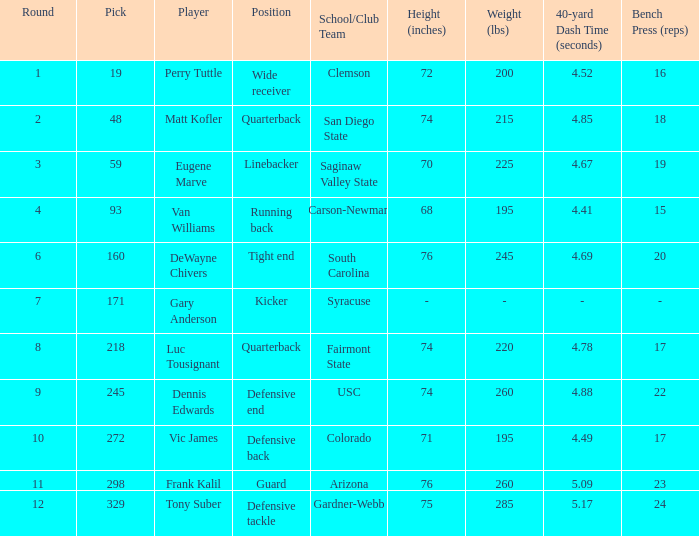Which player's pick is 160? DeWayne Chivers. 